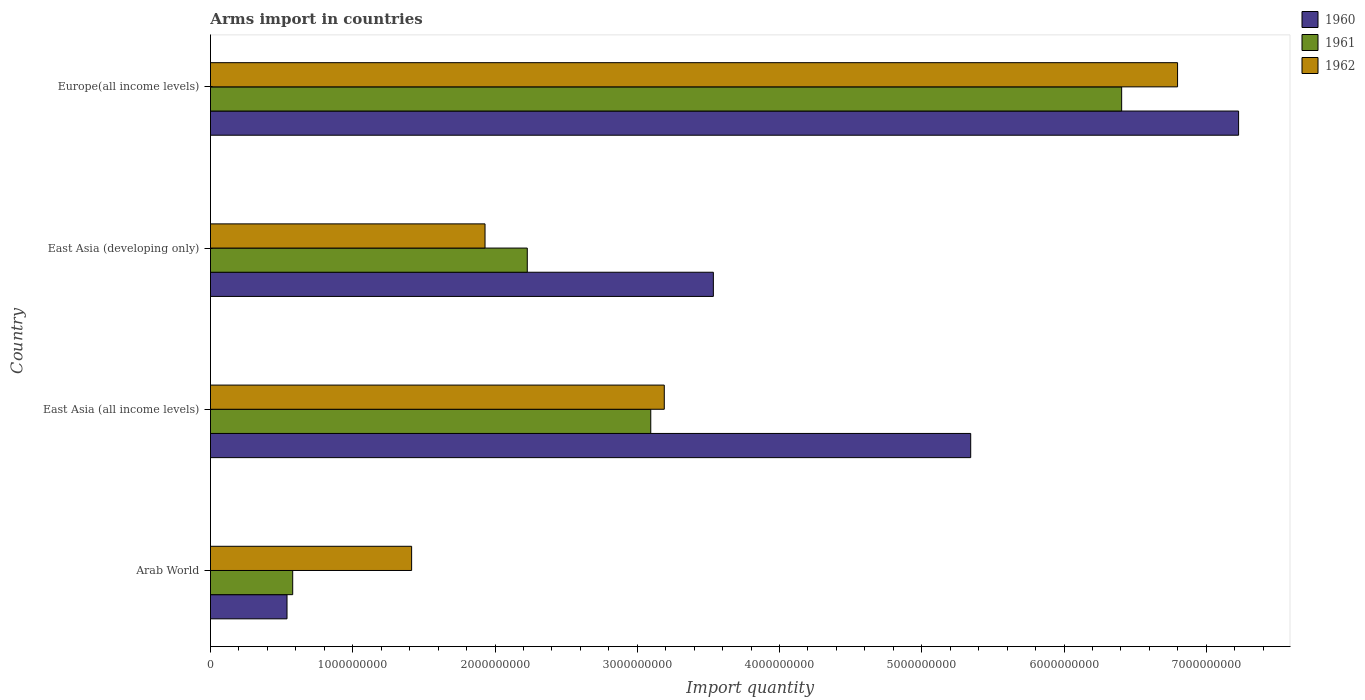How many groups of bars are there?
Offer a very short reply. 4. Are the number of bars per tick equal to the number of legend labels?
Offer a terse response. Yes. How many bars are there on the 2nd tick from the bottom?
Offer a terse response. 3. What is the label of the 1st group of bars from the top?
Offer a very short reply. Europe(all income levels). In how many cases, is the number of bars for a given country not equal to the number of legend labels?
Offer a terse response. 0. What is the total arms import in 1961 in Arab World?
Ensure brevity in your answer.  5.78e+08. Across all countries, what is the maximum total arms import in 1961?
Your response must be concise. 6.40e+09. Across all countries, what is the minimum total arms import in 1960?
Provide a succinct answer. 5.38e+08. In which country was the total arms import in 1962 maximum?
Keep it short and to the point. Europe(all income levels). In which country was the total arms import in 1962 minimum?
Keep it short and to the point. Arab World. What is the total total arms import in 1960 in the graph?
Make the answer very short. 1.66e+1. What is the difference between the total arms import in 1960 in Arab World and that in East Asia (all income levels)?
Offer a very short reply. -4.81e+09. What is the difference between the total arms import in 1960 in East Asia (all income levels) and the total arms import in 1962 in Arab World?
Offer a very short reply. 3.93e+09. What is the average total arms import in 1962 per country?
Make the answer very short. 3.33e+09. What is the difference between the total arms import in 1960 and total arms import in 1962 in East Asia (all income levels)?
Your response must be concise. 2.15e+09. In how many countries, is the total arms import in 1961 greater than 2400000000 ?
Your response must be concise. 2. What is the ratio of the total arms import in 1962 in Arab World to that in East Asia (developing only)?
Provide a succinct answer. 0.73. Is the total arms import in 1962 in Arab World less than that in East Asia (developing only)?
Make the answer very short. Yes. What is the difference between the highest and the second highest total arms import in 1962?
Offer a very short reply. 3.61e+09. What is the difference between the highest and the lowest total arms import in 1962?
Your response must be concise. 5.38e+09. In how many countries, is the total arms import in 1962 greater than the average total arms import in 1962 taken over all countries?
Provide a succinct answer. 1. Is the sum of the total arms import in 1962 in East Asia (developing only) and Europe(all income levels) greater than the maximum total arms import in 1961 across all countries?
Provide a short and direct response. Yes. What does the 2nd bar from the top in Arab World represents?
Keep it short and to the point. 1961. What does the 1st bar from the bottom in Arab World represents?
Ensure brevity in your answer.  1960. Is it the case that in every country, the sum of the total arms import in 1961 and total arms import in 1960 is greater than the total arms import in 1962?
Give a very brief answer. No. Are all the bars in the graph horizontal?
Provide a succinct answer. Yes. What is the difference between two consecutive major ticks on the X-axis?
Offer a terse response. 1.00e+09. Are the values on the major ticks of X-axis written in scientific E-notation?
Your answer should be compact. No. Does the graph contain any zero values?
Make the answer very short. No. What is the title of the graph?
Give a very brief answer. Arms import in countries. Does "2000" appear as one of the legend labels in the graph?
Make the answer very short. No. What is the label or title of the X-axis?
Make the answer very short. Import quantity. What is the Import quantity in 1960 in Arab World?
Keep it short and to the point. 5.38e+08. What is the Import quantity in 1961 in Arab World?
Provide a succinct answer. 5.78e+08. What is the Import quantity of 1962 in Arab World?
Make the answer very short. 1.41e+09. What is the Import quantity in 1960 in East Asia (all income levels)?
Your answer should be very brief. 5.34e+09. What is the Import quantity of 1961 in East Asia (all income levels)?
Provide a succinct answer. 3.10e+09. What is the Import quantity of 1962 in East Asia (all income levels)?
Ensure brevity in your answer.  3.19e+09. What is the Import quantity in 1960 in East Asia (developing only)?
Your response must be concise. 3.54e+09. What is the Import quantity of 1961 in East Asia (developing only)?
Make the answer very short. 2.23e+09. What is the Import quantity of 1962 in East Asia (developing only)?
Offer a terse response. 1.93e+09. What is the Import quantity in 1960 in Europe(all income levels)?
Ensure brevity in your answer.  7.23e+09. What is the Import quantity in 1961 in Europe(all income levels)?
Give a very brief answer. 6.40e+09. What is the Import quantity in 1962 in Europe(all income levels)?
Give a very brief answer. 6.80e+09. Across all countries, what is the maximum Import quantity of 1960?
Keep it short and to the point. 7.23e+09. Across all countries, what is the maximum Import quantity of 1961?
Your answer should be very brief. 6.40e+09. Across all countries, what is the maximum Import quantity in 1962?
Provide a short and direct response. 6.80e+09. Across all countries, what is the minimum Import quantity in 1960?
Offer a terse response. 5.38e+08. Across all countries, what is the minimum Import quantity in 1961?
Offer a terse response. 5.78e+08. Across all countries, what is the minimum Import quantity in 1962?
Make the answer very short. 1.41e+09. What is the total Import quantity of 1960 in the graph?
Offer a terse response. 1.66e+1. What is the total Import quantity of 1961 in the graph?
Ensure brevity in your answer.  1.23e+1. What is the total Import quantity of 1962 in the graph?
Ensure brevity in your answer.  1.33e+1. What is the difference between the Import quantity in 1960 in Arab World and that in East Asia (all income levels)?
Your response must be concise. -4.81e+09. What is the difference between the Import quantity of 1961 in Arab World and that in East Asia (all income levels)?
Give a very brief answer. -2.52e+09. What is the difference between the Import quantity of 1962 in Arab World and that in East Asia (all income levels)?
Provide a short and direct response. -1.78e+09. What is the difference between the Import quantity of 1960 in Arab World and that in East Asia (developing only)?
Your response must be concise. -3.00e+09. What is the difference between the Import quantity of 1961 in Arab World and that in East Asia (developing only)?
Keep it short and to the point. -1.65e+09. What is the difference between the Import quantity in 1962 in Arab World and that in East Asia (developing only)?
Ensure brevity in your answer.  -5.16e+08. What is the difference between the Import quantity of 1960 in Arab World and that in Europe(all income levels)?
Give a very brief answer. -6.69e+09. What is the difference between the Import quantity in 1961 in Arab World and that in Europe(all income levels)?
Your response must be concise. -5.83e+09. What is the difference between the Import quantity in 1962 in Arab World and that in Europe(all income levels)?
Your answer should be very brief. -5.38e+09. What is the difference between the Import quantity of 1960 in East Asia (all income levels) and that in East Asia (developing only)?
Provide a short and direct response. 1.81e+09. What is the difference between the Import quantity in 1961 in East Asia (all income levels) and that in East Asia (developing only)?
Provide a succinct answer. 8.68e+08. What is the difference between the Import quantity in 1962 in East Asia (all income levels) and that in East Asia (developing only)?
Offer a terse response. 1.26e+09. What is the difference between the Import quantity of 1960 in East Asia (all income levels) and that in Europe(all income levels)?
Provide a short and direct response. -1.88e+09. What is the difference between the Import quantity of 1961 in East Asia (all income levels) and that in Europe(all income levels)?
Give a very brief answer. -3.31e+09. What is the difference between the Import quantity in 1962 in East Asia (all income levels) and that in Europe(all income levels)?
Offer a terse response. -3.61e+09. What is the difference between the Import quantity in 1960 in East Asia (developing only) and that in Europe(all income levels)?
Make the answer very short. -3.69e+09. What is the difference between the Import quantity in 1961 in East Asia (developing only) and that in Europe(all income levels)?
Ensure brevity in your answer.  -4.18e+09. What is the difference between the Import quantity of 1962 in East Asia (developing only) and that in Europe(all income levels)?
Provide a succinct answer. -4.87e+09. What is the difference between the Import quantity of 1960 in Arab World and the Import quantity of 1961 in East Asia (all income levels)?
Give a very brief answer. -2.56e+09. What is the difference between the Import quantity of 1960 in Arab World and the Import quantity of 1962 in East Asia (all income levels)?
Make the answer very short. -2.65e+09. What is the difference between the Import quantity of 1961 in Arab World and the Import quantity of 1962 in East Asia (all income levels)?
Make the answer very short. -2.61e+09. What is the difference between the Import quantity of 1960 in Arab World and the Import quantity of 1961 in East Asia (developing only)?
Provide a short and direct response. -1.69e+09. What is the difference between the Import quantity of 1960 in Arab World and the Import quantity of 1962 in East Asia (developing only)?
Your answer should be very brief. -1.39e+09. What is the difference between the Import quantity in 1961 in Arab World and the Import quantity in 1962 in East Asia (developing only)?
Ensure brevity in your answer.  -1.35e+09. What is the difference between the Import quantity of 1960 in Arab World and the Import quantity of 1961 in Europe(all income levels)?
Ensure brevity in your answer.  -5.87e+09. What is the difference between the Import quantity of 1960 in Arab World and the Import quantity of 1962 in Europe(all income levels)?
Ensure brevity in your answer.  -6.26e+09. What is the difference between the Import quantity of 1961 in Arab World and the Import quantity of 1962 in Europe(all income levels)?
Give a very brief answer. -6.22e+09. What is the difference between the Import quantity of 1960 in East Asia (all income levels) and the Import quantity of 1961 in East Asia (developing only)?
Provide a short and direct response. 3.12e+09. What is the difference between the Import quantity of 1960 in East Asia (all income levels) and the Import quantity of 1962 in East Asia (developing only)?
Your response must be concise. 3.41e+09. What is the difference between the Import quantity in 1961 in East Asia (all income levels) and the Import quantity in 1962 in East Asia (developing only)?
Keep it short and to the point. 1.16e+09. What is the difference between the Import quantity of 1960 in East Asia (all income levels) and the Import quantity of 1961 in Europe(all income levels)?
Your answer should be compact. -1.06e+09. What is the difference between the Import quantity in 1960 in East Asia (all income levels) and the Import quantity in 1962 in Europe(all income levels)?
Make the answer very short. -1.45e+09. What is the difference between the Import quantity in 1961 in East Asia (all income levels) and the Import quantity in 1962 in Europe(all income levels)?
Make the answer very short. -3.70e+09. What is the difference between the Import quantity in 1960 in East Asia (developing only) and the Import quantity in 1961 in Europe(all income levels)?
Your response must be concise. -2.87e+09. What is the difference between the Import quantity of 1960 in East Asia (developing only) and the Import quantity of 1962 in Europe(all income levels)?
Give a very brief answer. -3.26e+09. What is the difference between the Import quantity of 1961 in East Asia (developing only) and the Import quantity of 1962 in Europe(all income levels)?
Make the answer very short. -4.57e+09. What is the average Import quantity of 1960 per country?
Keep it short and to the point. 4.16e+09. What is the average Import quantity of 1961 per country?
Provide a succinct answer. 3.08e+09. What is the average Import quantity in 1962 per country?
Provide a short and direct response. 3.33e+09. What is the difference between the Import quantity in 1960 and Import quantity in 1961 in Arab World?
Give a very brief answer. -4.00e+07. What is the difference between the Import quantity of 1960 and Import quantity of 1962 in Arab World?
Make the answer very short. -8.76e+08. What is the difference between the Import quantity of 1961 and Import quantity of 1962 in Arab World?
Provide a short and direct response. -8.36e+08. What is the difference between the Import quantity of 1960 and Import quantity of 1961 in East Asia (all income levels)?
Provide a succinct answer. 2.25e+09. What is the difference between the Import quantity in 1960 and Import quantity in 1962 in East Asia (all income levels)?
Ensure brevity in your answer.  2.15e+09. What is the difference between the Import quantity in 1961 and Import quantity in 1962 in East Asia (all income levels)?
Provide a succinct answer. -9.50e+07. What is the difference between the Import quantity in 1960 and Import quantity in 1961 in East Asia (developing only)?
Keep it short and to the point. 1.31e+09. What is the difference between the Import quantity of 1960 and Import quantity of 1962 in East Asia (developing only)?
Provide a succinct answer. 1.60e+09. What is the difference between the Import quantity of 1961 and Import quantity of 1962 in East Asia (developing only)?
Your answer should be compact. 2.97e+08. What is the difference between the Import quantity in 1960 and Import quantity in 1961 in Europe(all income levels)?
Offer a terse response. 8.22e+08. What is the difference between the Import quantity of 1960 and Import quantity of 1962 in Europe(all income levels)?
Your response must be concise. 4.29e+08. What is the difference between the Import quantity of 1961 and Import quantity of 1962 in Europe(all income levels)?
Give a very brief answer. -3.93e+08. What is the ratio of the Import quantity in 1960 in Arab World to that in East Asia (all income levels)?
Give a very brief answer. 0.1. What is the ratio of the Import quantity of 1961 in Arab World to that in East Asia (all income levels)?
Provide a short and direct response. 0.19. What is the ratio of the Import quantity of 1962 in Arab World to that in East Asia (all income levels)?
Provide a succinct answer. 0.44. What is the ratio of the Import quantity in 1960 in Arab World to that in East Asia (developing only)?
Your answer should be very brief. 0.15. What is the ratio of the Import quantity of 1961 in Arab World to that in East Asia (developing only)?
Offer a very short reply. 0.26. What is the ratio of the Import quantity of 1962 in Arab World to that in East Asia (developing only)?
Offer a terse response. 0.73. What is the ratio of the Import quantity in 1960 in Arab World to that in Europe(all income levels)?
Make the answer very short. 0.07. What is the ratio of the Import quantity in 1961 in Arab World to that in Europe(all income levels)?
Provide a short and direct response. 0.09. What is the ratio of the Import quantity of 1962 in Arab World to that in Europe(all income levels)?
Your answer should be very brief. 0.21. What is the ratio of the Import quantity in 1960 in East Asia (all income levels) to that in East Asia (developing only)?
Make the answer very short. 1.51. What is the ratio of the Import quantity in 1961 in East Asia (all income levels) to that in East Asia (developing only)?
Give a very brief answer. 1.39. What is the ratio of the Import quantity in 1962 in East Asia (all income levels) to that in East Asia (developing only)?
Your answer should be very brief. 1.65. What is the ratio of the Import quantity of 1960 in East Asia (all income levels) to that in Europe(all income levels)?
Keep it short and to the point. 0.74. What is the ratio of the Import quantity of 1961 in East Asia (all income levels) to that in Europe(all income levels)?
Offer a very short reply. 0.48. What is the ratio of the Import quantity of 1962 in East Asia (all income levels) to that in Europe(all income levels)?
Offer a very short reply. 0.47. What is the ratio of the Import quantity of 1960 in East Asia (developing only) to that in Europe(all income levels)?
Make the answer very short. 0.49. What is the ratio of the Import quantity of 1961 in East Asia (developing only) to that in Europe(all income levels)?
Give a very brief answer. 0.35. What is the ratio of the Import quantity in 1962 in East Asia (developing only) to that in Europe(all income levels)?
Your answer should be very brief. 0.28. What is the difference between the highest and the second highest Import quantity in 1960?
Your answer should be compact. 1.88e+09. What is the difference between the highest and the second highest Import quantity in 1961?
Your answer should be very brief. 3.31e+09. What is the difference between the highest and the second highest Import quantity of 1962?
Make the answer very short. 3.61e+09. What is the difference between the highest and the lowest Import quantity of 1960?
Your answer should be compact. 6.69e+09. What is the difference between the highest and the lowest Import quantity in 1961?
Make the answer very short. 5.83e+09. What is the difference between the highest and the lowest Import quantity in 1962?
Your answer should be compact. 5.38e+09. 